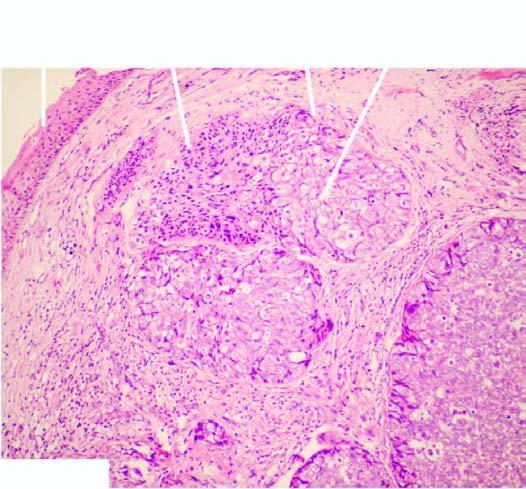what are the tumour cells arranged as with?
Answer the question using a single word or phrase. Lobules with peripheral basaloid cells and pale cells in the centre 